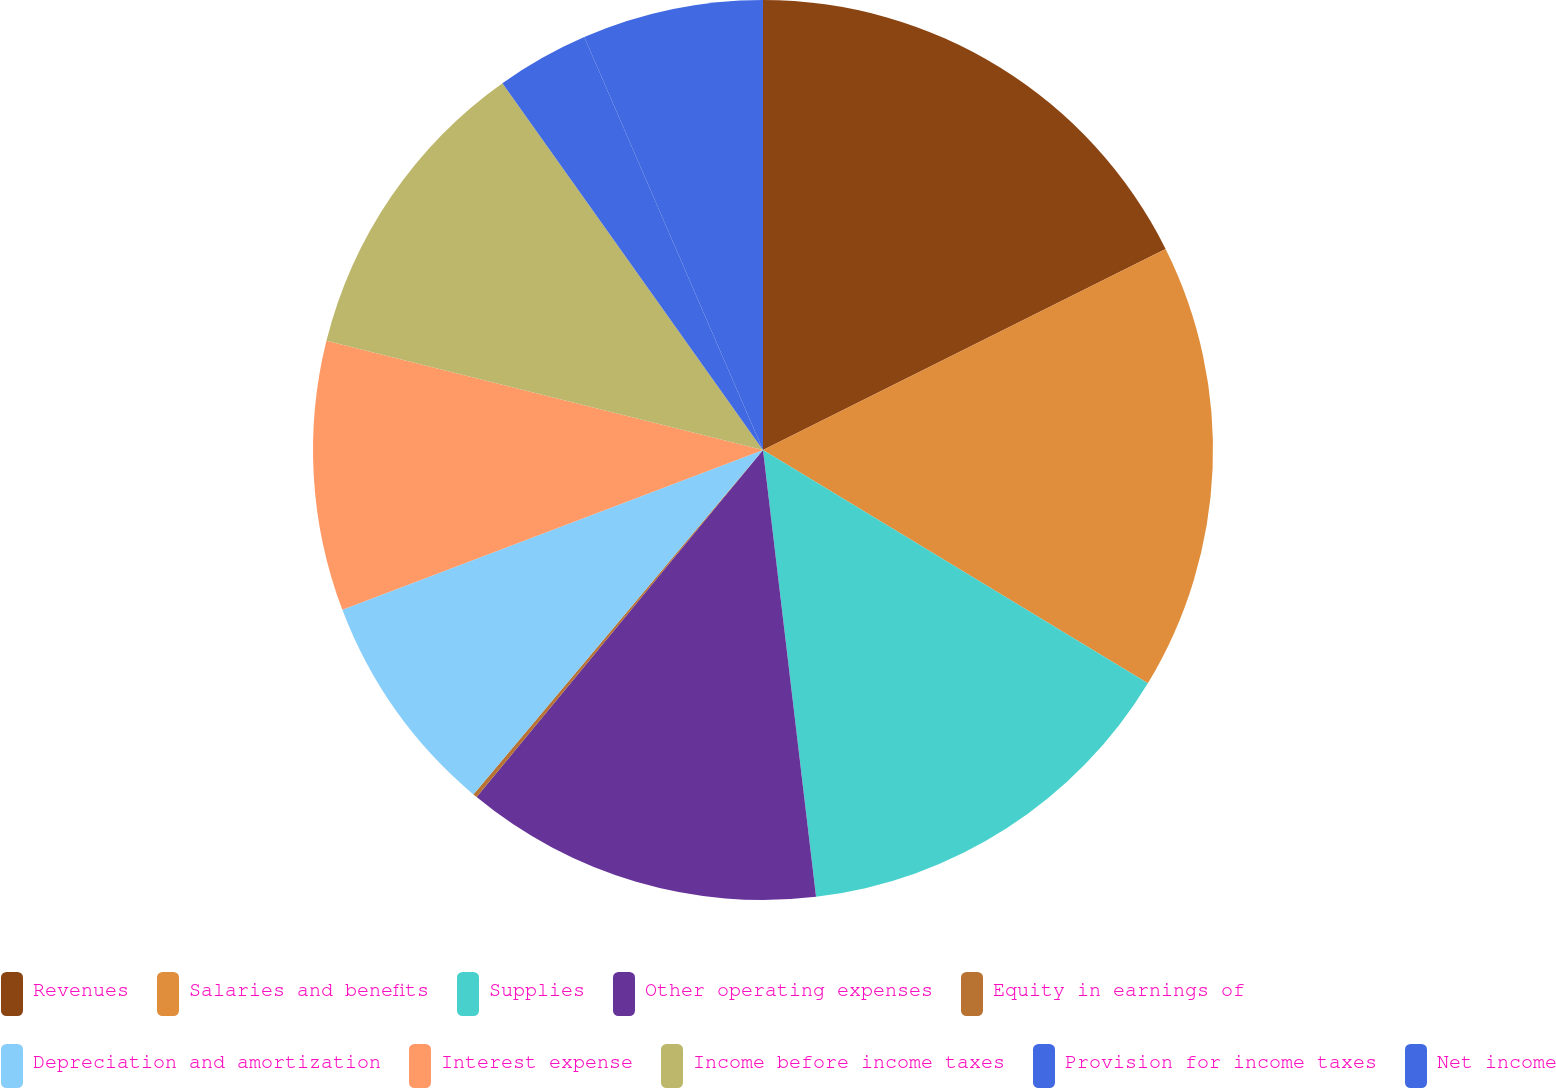Convert chart to OTSL. <chart><loc_0><loc_0><loc_500><loc_500><pie_chart><fcel>Revenues<fcel>Salaries and benefits<fcel>Supplies<fcel>Other operating expenses<fcel>Equity in earnings of<fcel>Depreciation and amortization<fcel>Interest expense<fcel>Income before income taxes<fcel>Provision for income taxes<fcel>Net income<nl><fcel>17.63%<fcel>16.04%<fcel>14.45%<fcel>12.86%<fcel>0.15%<fcel>8.09%<fcel>9.68%<fcel>11.27%<fcel>3.33%<fcel>6.5%<nl></chart> 